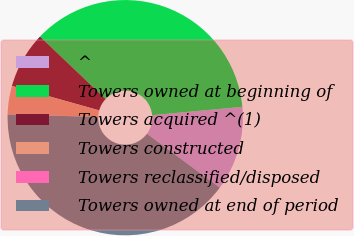<chart> <loc_0><loc_0><loc_500><loc_500><pie_chart><fcel>^<fcel>Towers owned at beginning of<fcel>Towers acquired ^(1)<fcel>Towers constructed<fcel>Towers reclassified/disposed<fcel>Towers owned at end of period<nl><fcel>11.61%<fcel>36.43%<fcel>7.75%<fcel>3.89%<fcel>0.03%<fcel>40.29%<nl></chart> 